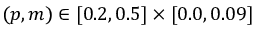Convert formula to latex. <formula><loc_0><loc_0><loc_500><loc_500>( p , m ) \in [ 0 . 2 , 0 . 5 ] \times [ 0 . 0 , 0 . 0 9 ]</formula> 